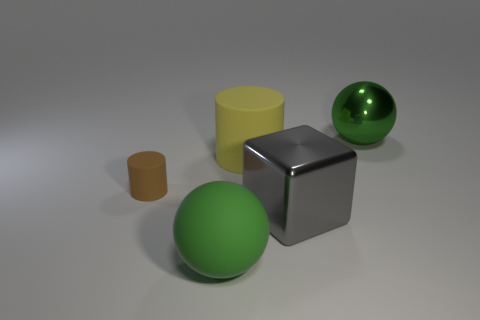There is a shiny sphere that is the same color as the big matte ball; what size is it?
Your response must be concise. Large. Do the rubber ball and the big ball that is behind the brown cylinder have the same color?
Make the answer very short. Yes. What shape is the rubber object that is the same color as the metal ball?
Provide a short and direct response. Sphere. What number of objects are green shiny things or small yellow rubber cylinders?
Keep it short and to the point. 1. Is the number of small brown rubber things that are right of the block less than the number of small cylinders?
Provide a short and direct response. Yes. Are there more big matte things to the left of the big cylinder than cylinders to the right of the gray shiny object?
Make the answer very short. Yes. Are there any other things that are the same color as the shiny ball?
Give a very brief answer. Yes. There is a cylinder that is to the right of the green rubber object; what is it made of?
Your response must be concise. Rubber. Is the size of the metallic ball the same as the brown cylinder?
Give a very brief answer. No. What number of other objects are the same size as the brown object?
Offer a very short reply. 0. 